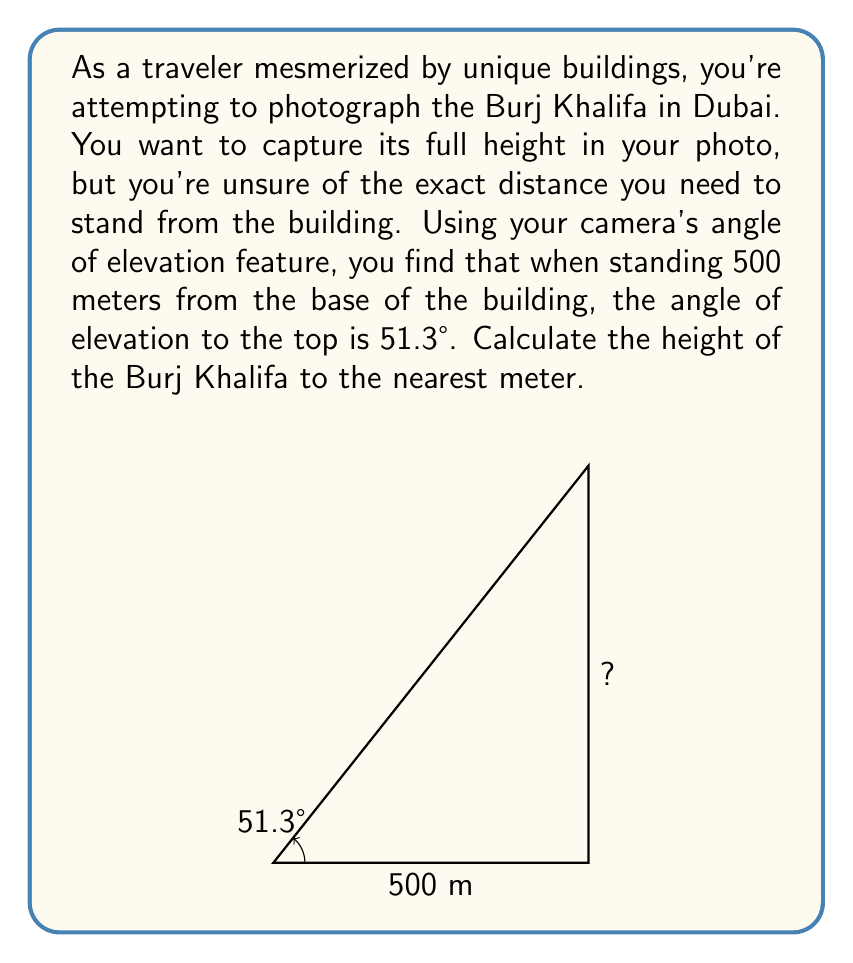Provide a solution to this math problem. Let's approach this problem step-by-step using trigonometry:

1) In this scenario, we have a right triangle where:
   - The base of the triangle is the distance from you to the building (500 meters)
   - The height of the triangle is the height of the building (what we're solving for)
   - The angle of elevation is 51.3°

2) We can use the tangent function to solve for the height. Recall that:

   $$ \tan(\theta) = \frac{\text{opposite}}{\text{adjacent}} = \frac{\text{height}}{\text{base}} $$

3) Let's call the height $h$. We can set up the equation:

   $$ \tan(51.3°) = \frac{h}{500} $$

4) To solve for $h$, we multiply both sides by 500:

   $$ h = 500 \cdot \tan(51.3°) $$

5) Now we can calculate:
   
   $$ h = 500 \cdot \tan(51.3°) \approx 500 \cdot 1.25620 \approx 628.10 \text{ meters} $$

6) Rounding to the nearest meter as requested:

   $$ h \approx 628 \text{ meters} $$

This calculated height is quite close to the actual height of the Burj Khalifa, which is 828 meters to the tip. The difference could be due to factors such as the exact point of measurement or slight inaccuracies in the angle measurement.
Answer: The height of the Burj Khalifa, based on the given measurements, is approximately 628 meters. 